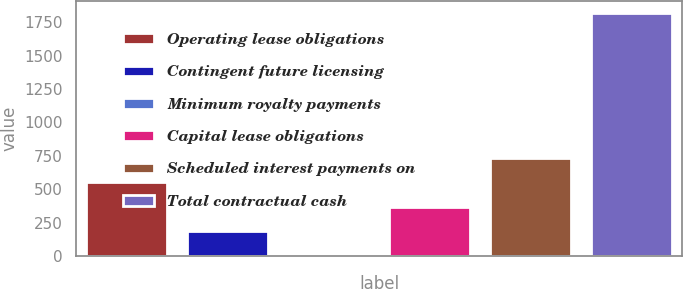Convert chart to OTSL. <chart><loc_0><loc_0><loc_500><loc_500><bar_chart><fcel>Operating lease obligations<fcel>Contingent future licensing<fcel>Minimum royalty payments<fcel>Capital lease obligations<fcel>Scheduled interest payments on<fcel>Total contractual cash<nl><fcel>549.82<fcel>188.34<fcel>7.6<fcel>369.08<fcel>730.56<fcel>1815<nl></chart> 